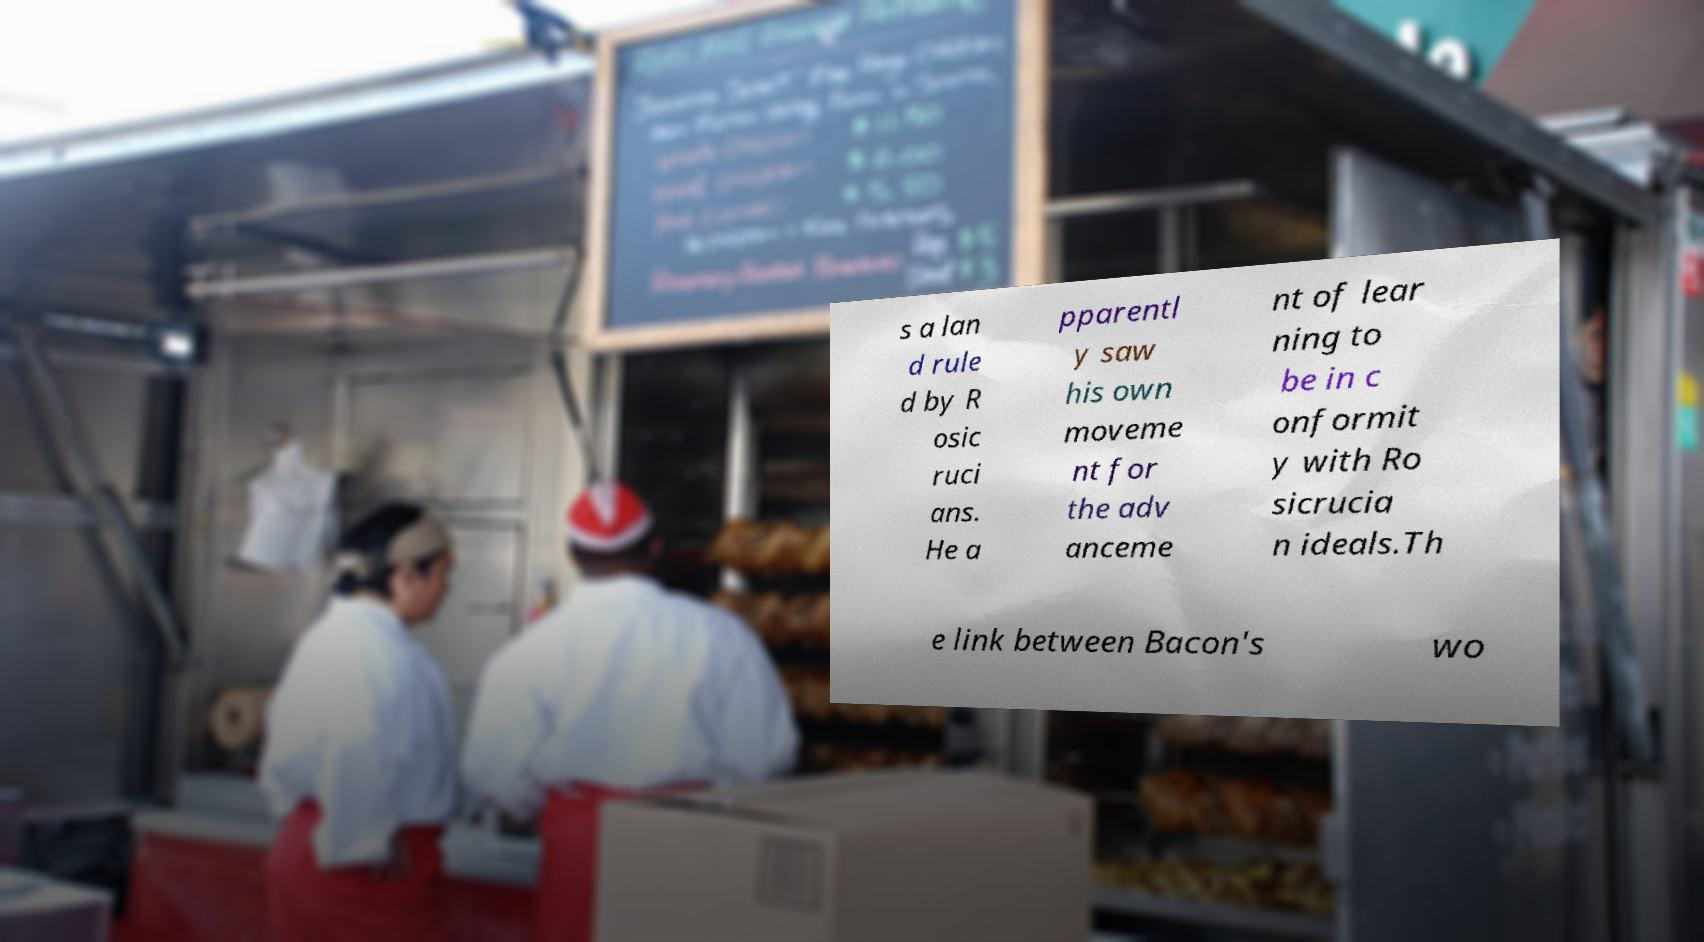Can you accurately transcribe the text from the provided image for me? s a lan d rule d by R osic ruci ans. He a pparentl y saw his own moveme nt for the adv anceme nt of lear ning to be in c onformit y with Ro sicrucia n ideals.Th e link between Bacon's wo 